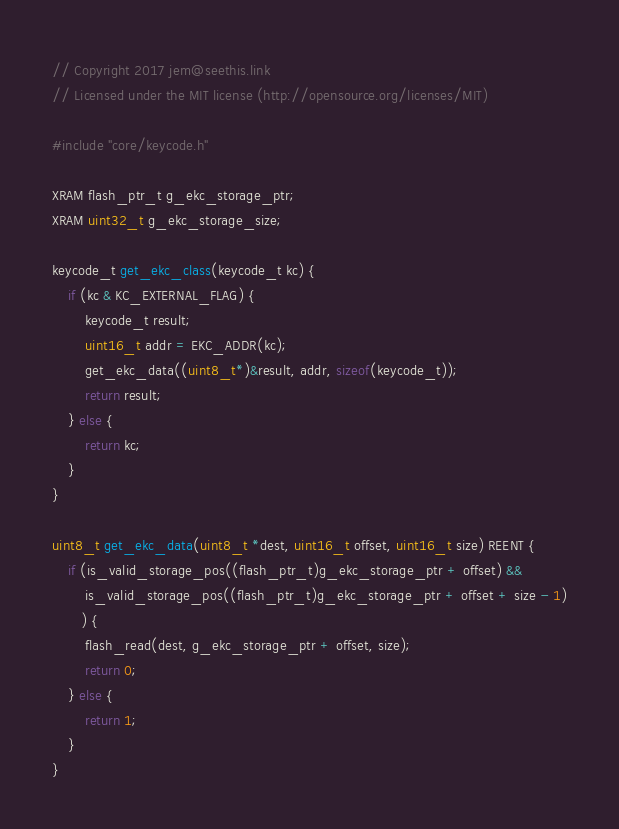Convert code to text. <code><loc_0><loc_0><loc_500><loc_500><_C_>// Copyright 2017 jem@seethis.link
// Licensed under the MIT license (http://opensource.org/licenses/MIT)

#include "core/keycode.h"

XRAM flash_ptr_t g_ekc_storage_ptr;
XRAM uint32_t g_ekc_storage_size;

keycode_t get_ekc_class(keycode_t kc) {
    if (kc & KC_EXTERNAL_FLAG) {
        keycode_t result;
        uint16_t addr = EKC_ADDR(kc);
        get_ekc_data((uint8_t*)&result, addr, sizeof(keycode_t));
        return result;
    } else {
        return kc;
    }
}

uint8_t get_ekc_data(uint8_t *dest, uint16_t offset, uint16_t size) REENT {
    if (is_valid_storage_pos((flash_ptr_t)g_ekc_storage_ptr + offset) &&
        is_valid_storage_pos((flash_ptr_t)g_ekc_storage_ptr + offset + size - 1)
       ) {
        flash_read(dest, g_ekc_storage_ptr + offset, size);
        return 0;
    } else {
        return 1;
    }
}
</code> 